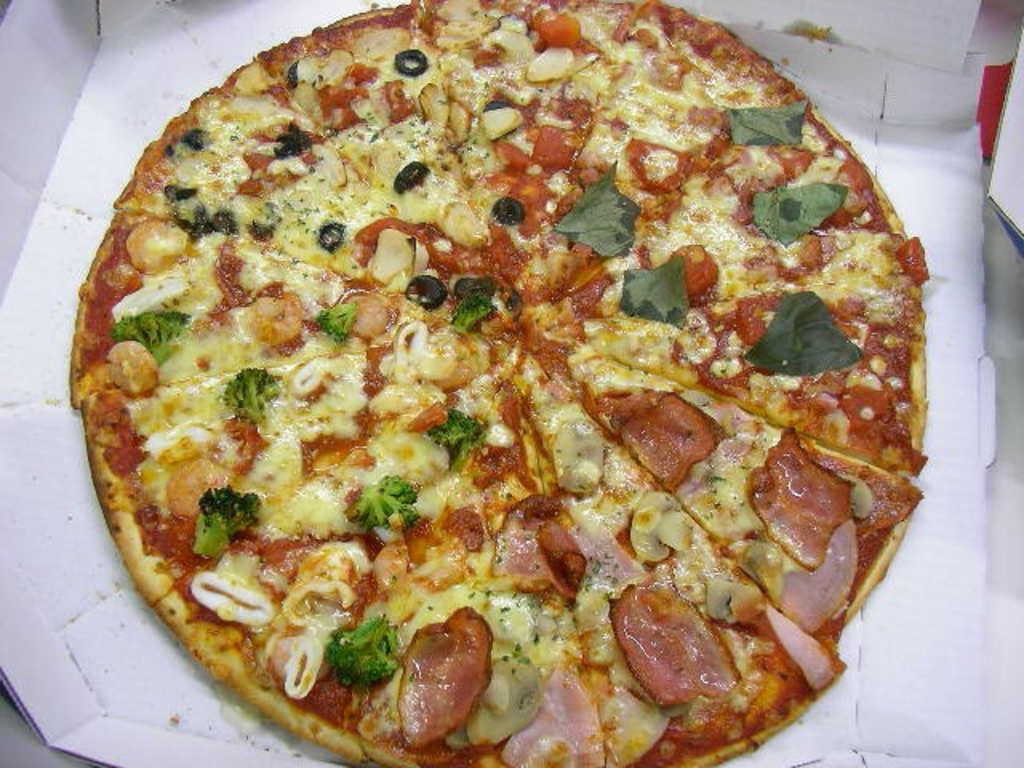Describe this image in one or two sentences. This picture shows a large pizza with some veggies, meat and cheese on it and we see a box. 